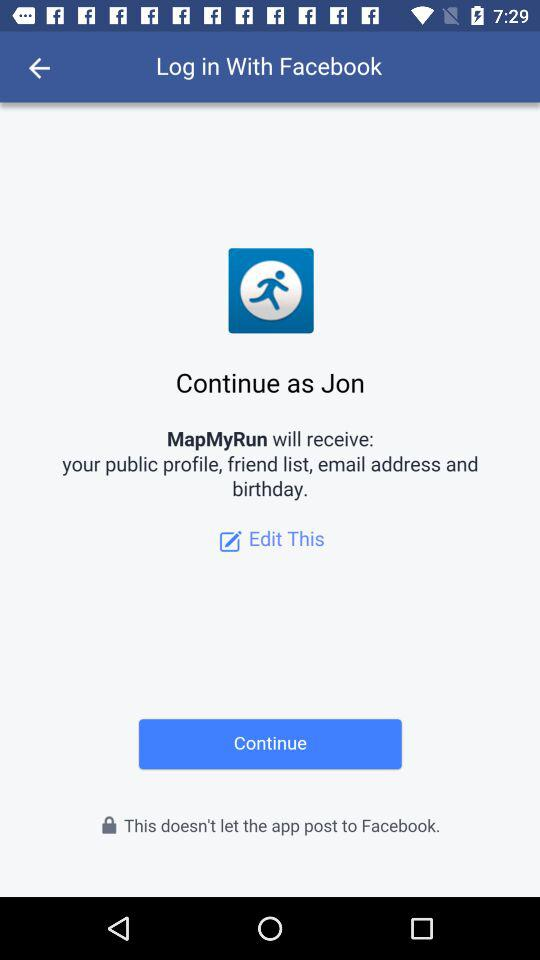What is the login name? The login name is Jon. 